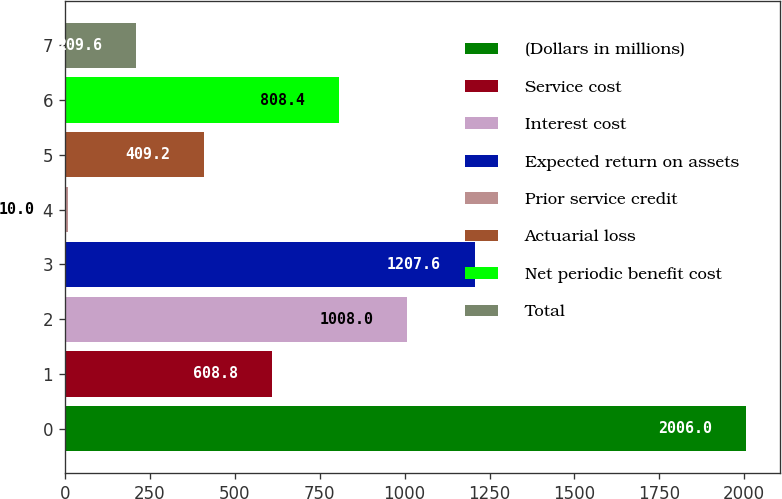Convert chart to OTSL. <chart><loc_0><loc_0><loc_500><loc_500><bar_chart><fcel>(Dollars in millions)<fcel>Service cost<fcel>Interest cost<fcel>Expected return on assets<fcel>Prior service credit<fcel>Actuarial loss<fcel>Net periodic benefit cost<fcel>Total<nl><fcel>2006<fcel>608.8<fcel>1008<fcel>1207.6<fcel>10<fcel>409.2<fcel>808.4<fcel>209.6<nl></chart> 